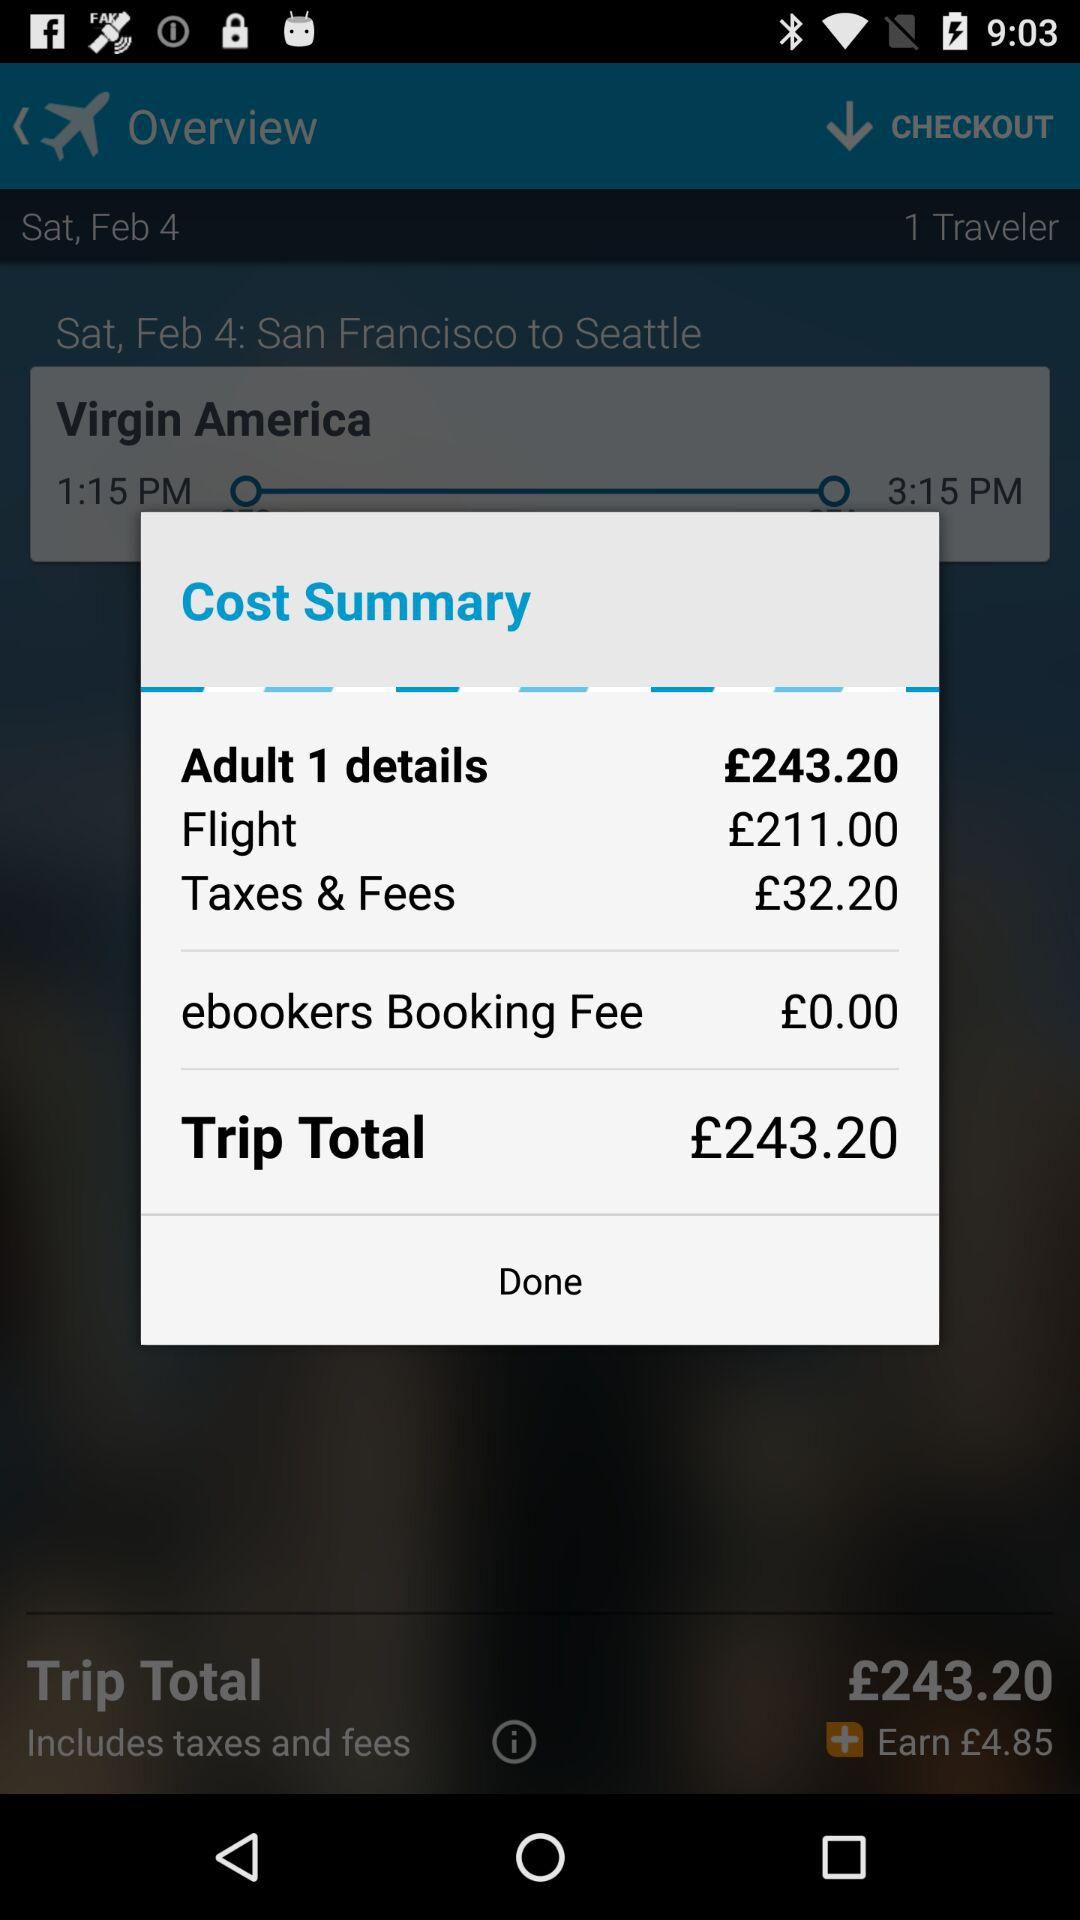How much are the taxes and fees? The taxes and fees are £32.20. 